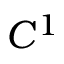Convert formula to latex. <formula><loc_0><loc_0><loc_500><loc_500>C ^ { 1 }</formula> 